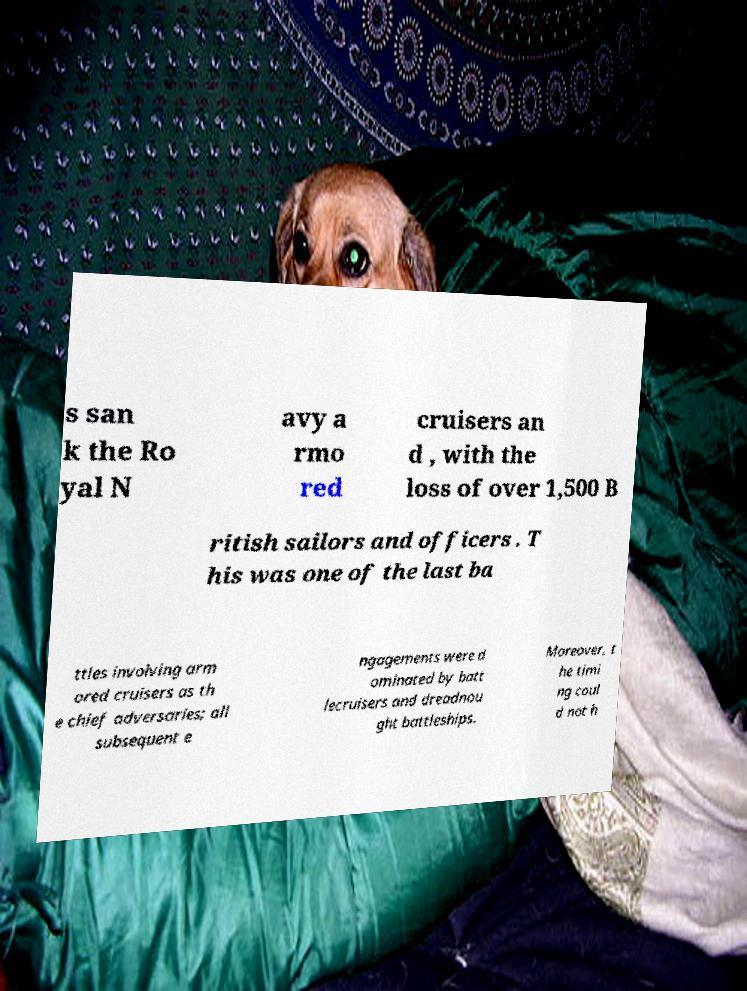Can you accurately transcribe the text from the provided image for me? s san k the Ro yal N avy a rmo red cruisers an d , with the loss of over 1,500 B ritish sailors and officers . T his was one of the last ba ttles involving arm ored cruisers as th e chief adversaries; all subsequent e ngagements were d ominated by batt lecruisers and dreadnou ght battleships. Moreover, t he timi ng coul d not h 